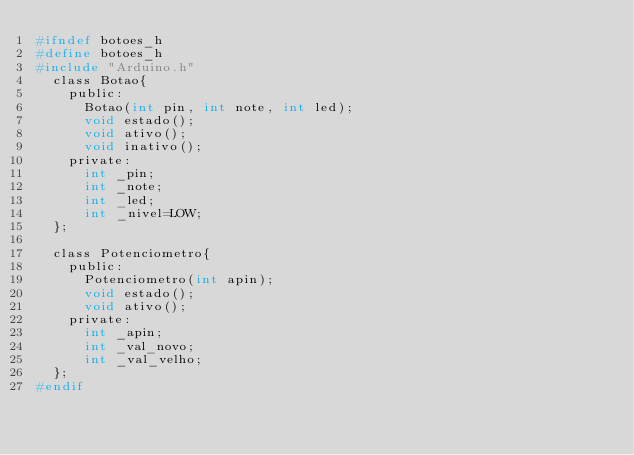Convert code to text. <code><loc_0><loc_0><loc_500><loc_500><_C_>#ifndef botoes_h
#define botoes_h
#include "Arduino.h"
  class Botao{
    public:
    	Botao(int pin, int note, int led);
    	void estado();
    	void ativo();
    	void inativo();
    private:
    	int _pin;
    	int _note;
    	int _led;
    	int _nivel=LOW;
  };

  class Potenciometro{
    public:
      Potenciometro(int apin);
      void estado();
      void ativo();
    private:
      int _apin;
      int _val_novo;
      int _val_velho;
  };
#endif
</code> 